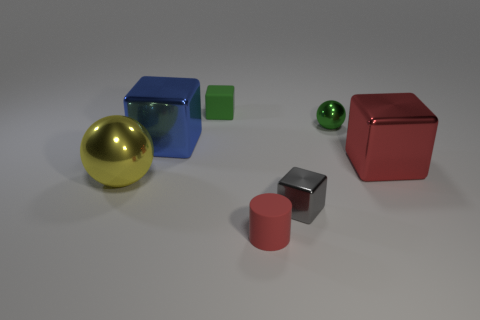Add 2 big blocks. How many objects exist? 9 Subtract all small green rubber cubes. How many cubes are left? 3 Subtract all blue cubes. How many cubes are left? 3 Subtract 1 blocks. How many blocks are left? 3 Subtract all tiny green matte objects. Subtract all tiny green rubber blocks. How many objects are left? 5 Add 1 large things. How many large things are left? 4 Add 6 large rubber cylinders. How many large rubber cylinders exist? 6 Subtract 0 gray spheres. How many objects are left? 7 Subtract all blocks. How many objects are left? 3 Subtract all blue blocks. Subtract all cyan spheres. How many blocks are left? 3 